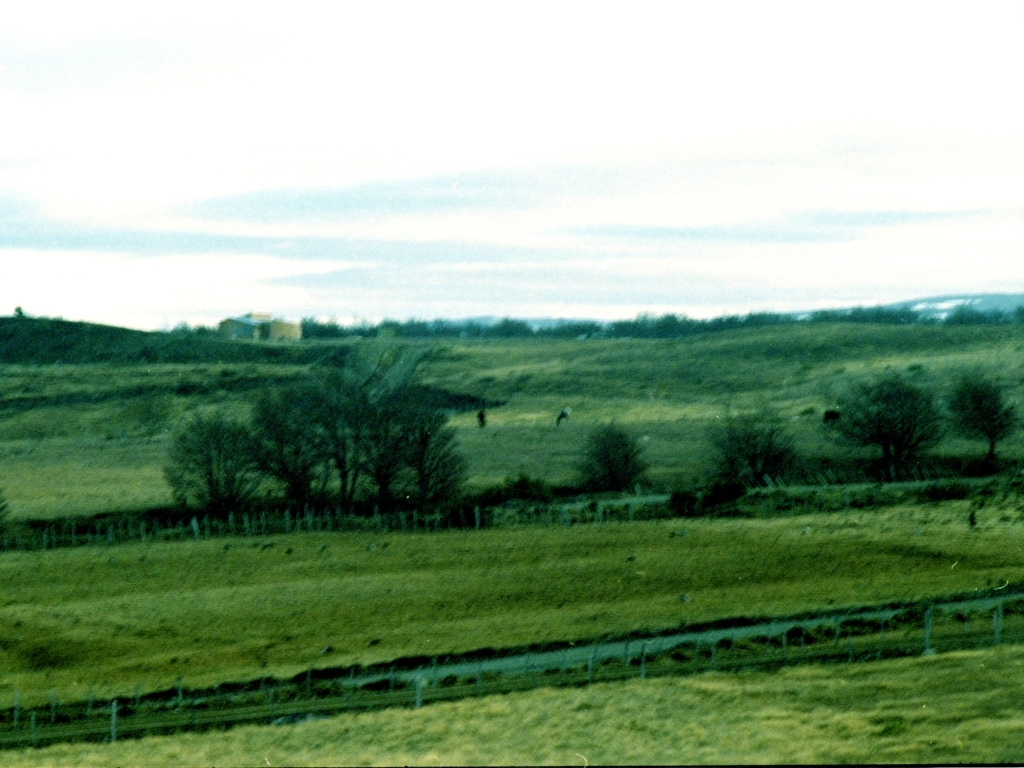What time of day does this image seem to capture? The photo appears to have been taken during the daytime, though the overcast sky impacts the lighting, giving the picture a somewhat muted quality typical of early morning or late afternoon. 